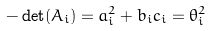<formula> <loc_0><loc_0><loc_500><loc_500>- \det ( A _ { i } ) = a _ { i } ^ { 2 } + b _ { i } c _ { i } = \theta _ { i } ^ { 2 }</formula> 